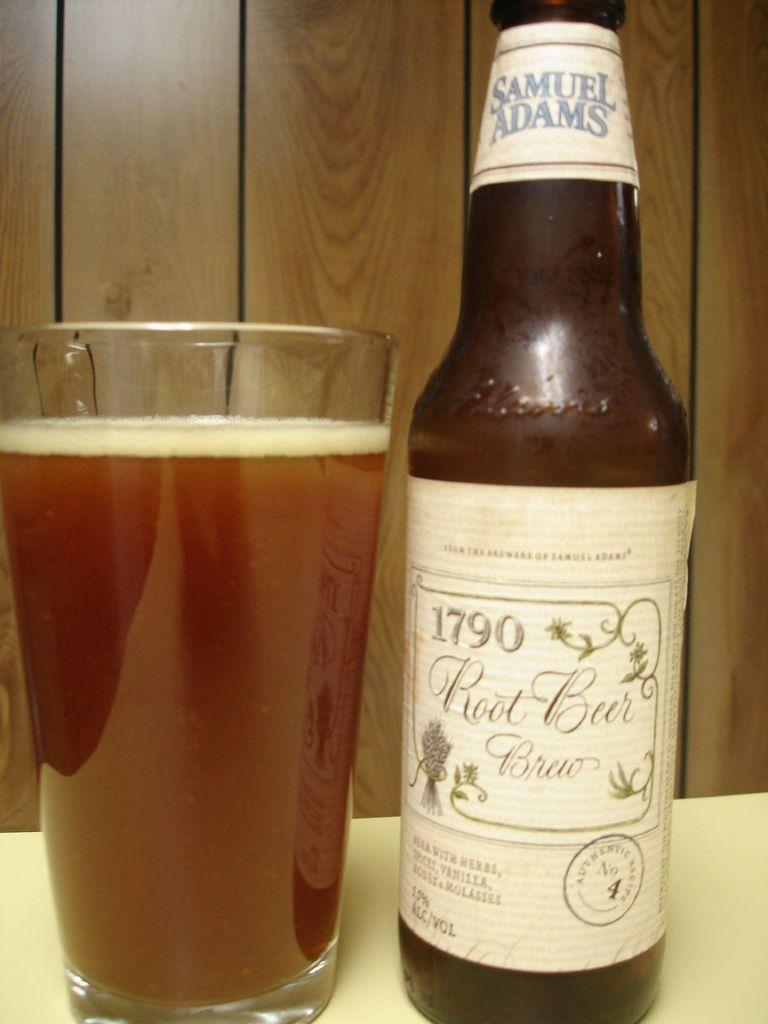<image>
Give a short and clear explanation of the subsequent image. A full glass next to a Samuel Adams bottle 